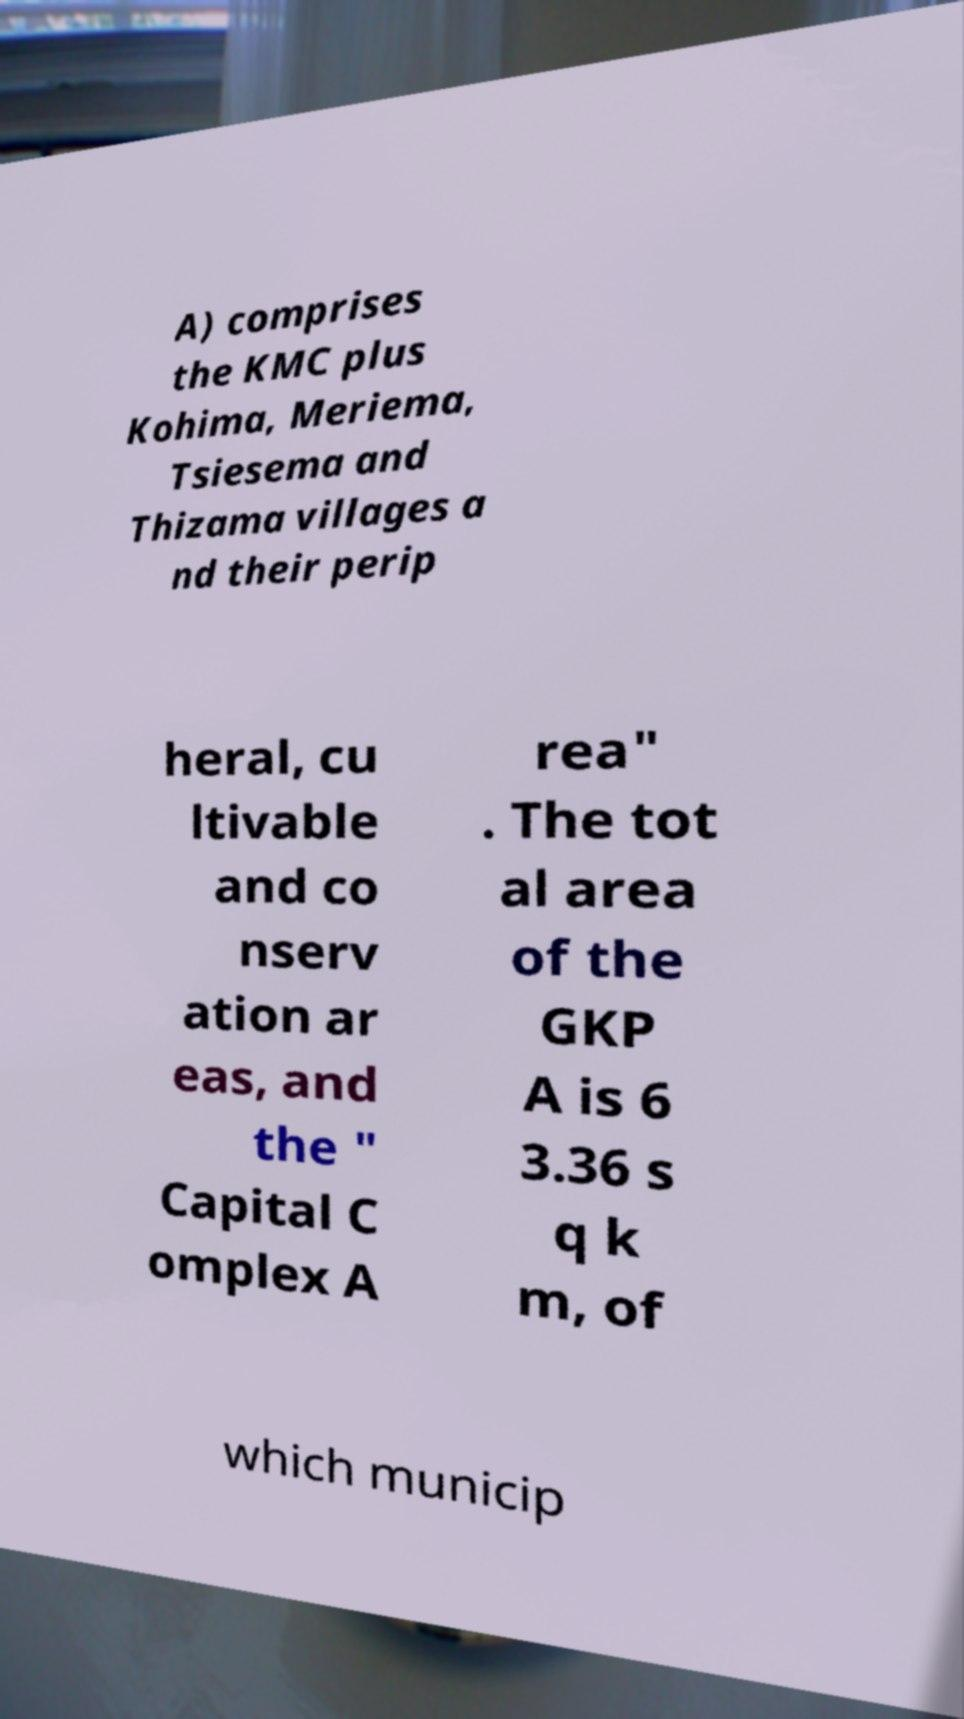For documentation purposes, I need the text within this image transcribed. Could you provide that? A) comprises the KMC plus Kohima, Meriema, Tsiesema and Thizama villages a nd their perip heral, cu ltivable and co nserv ation ar eas, and the " Capital C omplex A rea" . The tot al area of the GKP A is 6 3.36 s q k m, of which municip 